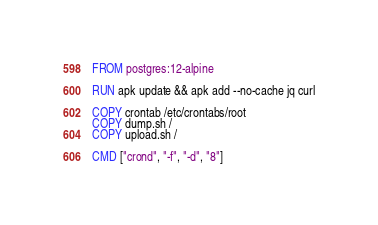<code> <loc_0><loc_0><loc_500><loc_500><_Dockerfile_>FROM postgres:12-alpine

RUN apk update && apk add --no-cache jq curl

COPY crontab /etc/crontabs/root
COPY dump.sh /
COPY upload.sh /

CMD ["crond", "-f", "-d", "8"]
</code> 